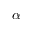<formula> <loc_0><loc_0><loc_500><loc_500>\alpha</formula> 